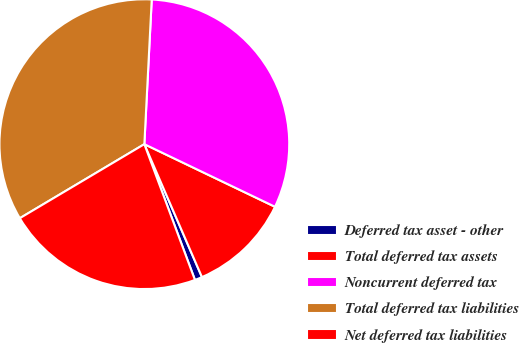Convert chart. <chart><loc_0><loc_0><loc_500><loc_500><pie_chart><fcel>Deferred tax asset - other<fcel>Total deferred tax assets<fcel>Noncurrent deferred tax<fcel>Total deferred tax liabilities<fcel>Net deferred tax liabilities<nl><fcel>0.83%<fcel>11.38%<fcel>31.3%<fcel>34.35%<fcel>22.14%<nl></chart> 